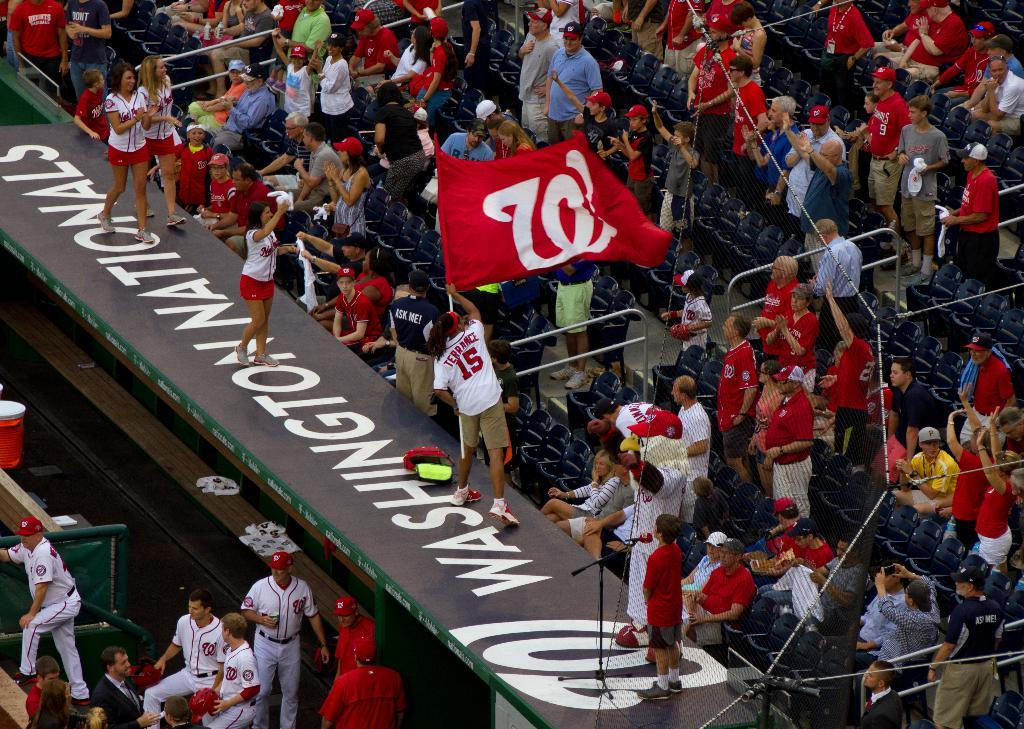<image>
Write a terse but informative summary of the picture. Washington Nationals stadium with view of dugout and bleachers. 